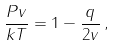<formula> <loc_0><loc_0><loc_500><loc_500>\frac { P v } { k T } = 1 - \frac { q } { 2 v } \, ,</formula> 